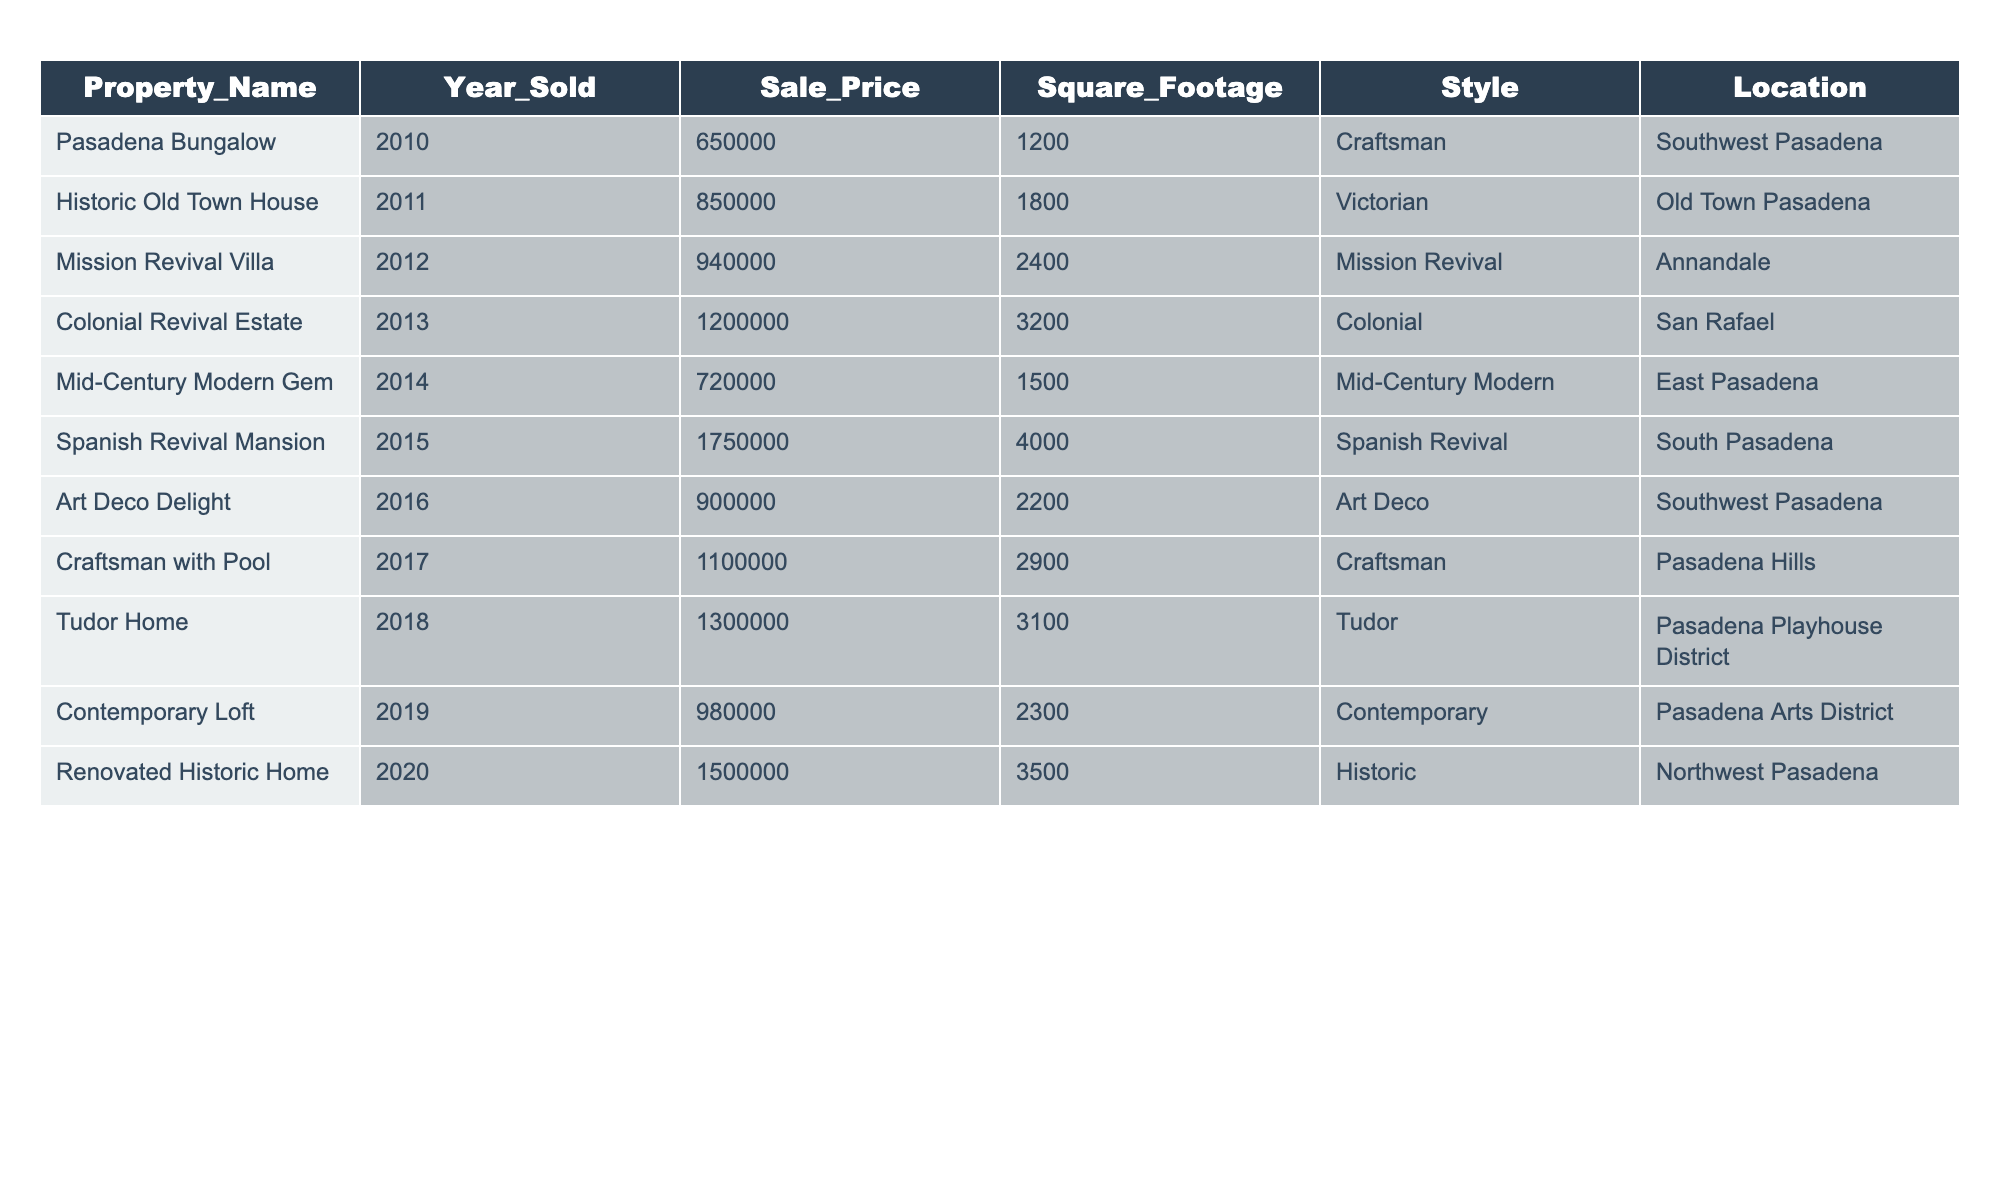What was the sale price of the Spanish Revival Mansion? The table shows that the Spanish Revival Mansion was sold in 2015 for a price of $1,750,000 as listed in the Sale_Price column.
Answer: $1,750,000 Which property had the lowest sale price? The table indicates that the Pasadena Bungalow sold for $650,000 in 2010, which is the lowest sale price among the listed properties.
Answer: Pasadena Bungalow What is the average sale price of all properties sold between 2010 and 2020? To find the average, sum all the sale prices: (650,000 + 850,000 + 940,000 + 1,200,000 + 720,000 + 1,750,000 + 900,000 + 1,100,000 + 1,300,000 + 980,000 + 1,500,000) = 11,090,000. There are 11 sales, so the average sale price is 11,090,000 / 11 = 1,008,182 approximately.
Answer: $1,008,182 What was the style of the property with the highest square footage? The property with the highest square footage is the Spanish Revival Mansion, which has 4,000 square feet as noted in the Square_Footage column. Its style is Spanish Revival.
Answer: Spanish Revival Did any property sell for over $1 million in 2014? The table indicates that the highest sale price in 2014 was for the Mid-Century Modern Gem, which sold for $720,000, therefore it is false that any property sold for over $1 million that year.
Answer: No How many properties in Old Town Pasadena were sold from 2010 to 2020? Referring to the Location column, the only property listed in Old Town Pasadena is the Historic Old Town House sold in 2011. Thus, there was only one property sold in that location during this period.
Answer: 1 What is the total square footage of all Tudor style homes sold? The table shows one Tudor home, the Tudor Home, which has a square footage of 3,100. Therefore, the total square footage for Tudor style homes sold is simply 3,100.
Answer: 3,100 How did the sale price of properties change from 2010 to 2020, based on the data? Reviewing the sale prices from 2010 ($650,000) to 2020 ($1,500,000), there was a significant increase in property values over the decade. Analyzing individual year changes shows an upward trend in sale prices across the majority of years.
Answer: Significant increase Which year had the second highest sale price, and what was it? By examining the Sale_Price column, the second highest sale price was in 2019 which was $980,000, while the highest sale price was in 2015 at $1,750,000.
Answer: 2019, $980,000 What type of architecture style is most commonly represented in this data? The data indicates there are multiple instances of Craftsmans and one for each of the other styles, but based solely on the information provided, Craftsman appears to be the most represented with two entries (Pasadena Bungalow and Craftsman with Pool).
Answer: Craftsman 